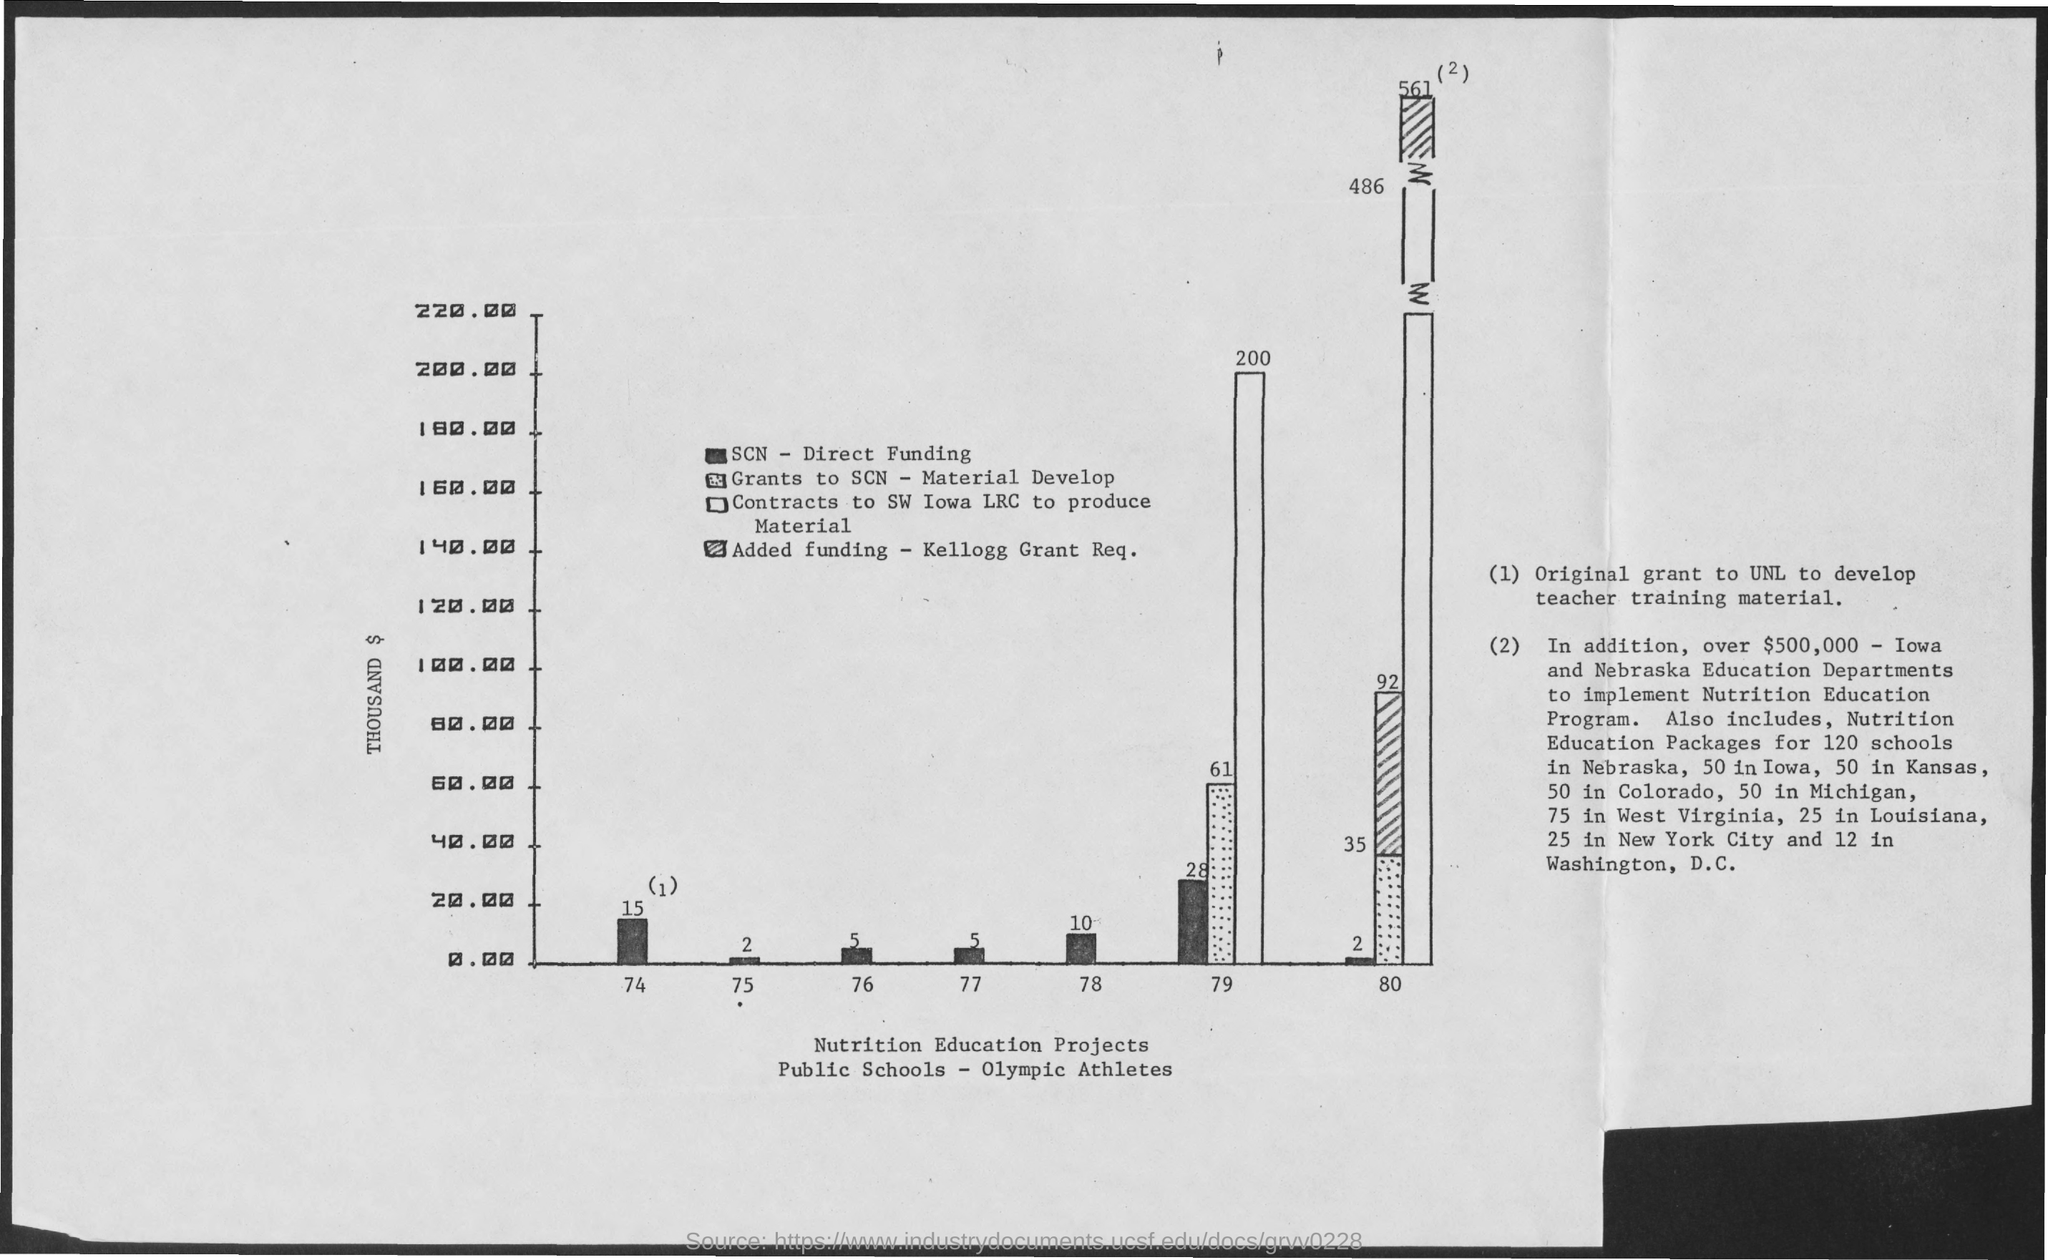What was the SCN - Direct Funding amount in 77?
Ensure brevity in your answer.  5 Thousand $. What was the SCN - Direct Funding amount in 74?
Offer a very short reply. 15 Thousand $. What was the SCN - Direct Funding amount in 75?
Keep it short and to the point. 2 Thousand $. What was the SCN - Direct Funding amount in 76?
Offer a terse response. 5 Thousand $. What was the SCN - Direct Funding amount in 78?
Your answer should be compact. 10 Thousand $. What was the total amount given for contracts to SW Iowa LRC to produce materials in 79?
Keep it short and to the point. 200 Thousand $. What was the total amount given as grants to SCN for material development in 79?
Offer a very short reply. 61 Thousand $. How much is SCN Direct funding in 77?
Offer a terse response. 5. What was the total amount given as grants to SCN for material development in 80?
Provide a short and direct response. 35 Thousand $. 